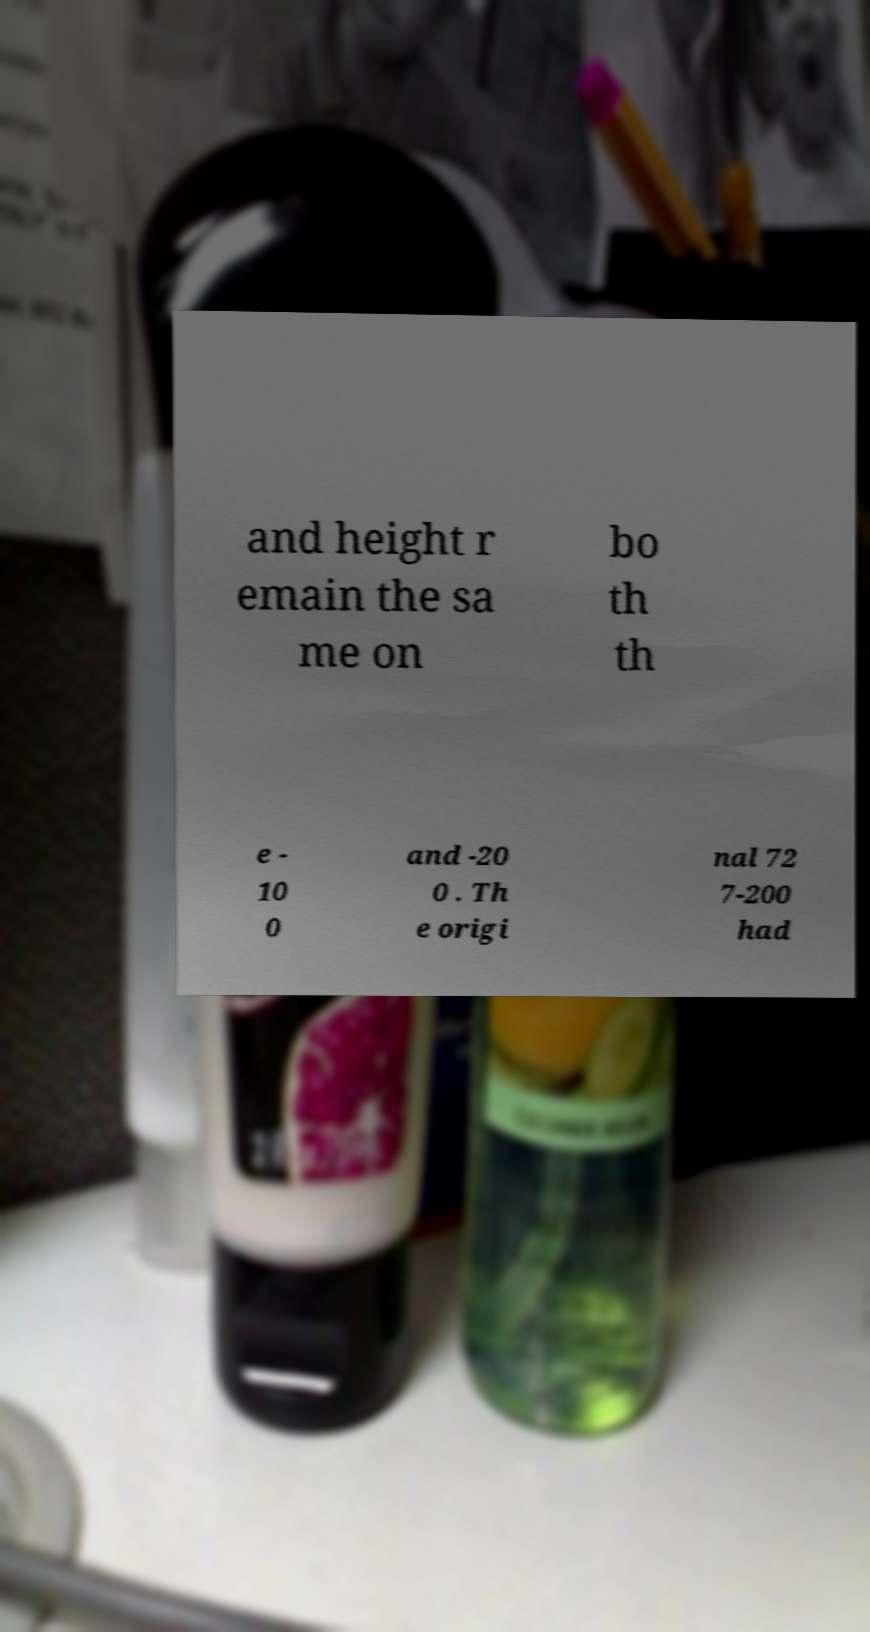Can you accurately transcribe the text from the provided image for me? and height r emain the sa me on bo th th e - 10 0 and -20 0 . Th e origi nal 72 7-200 had 